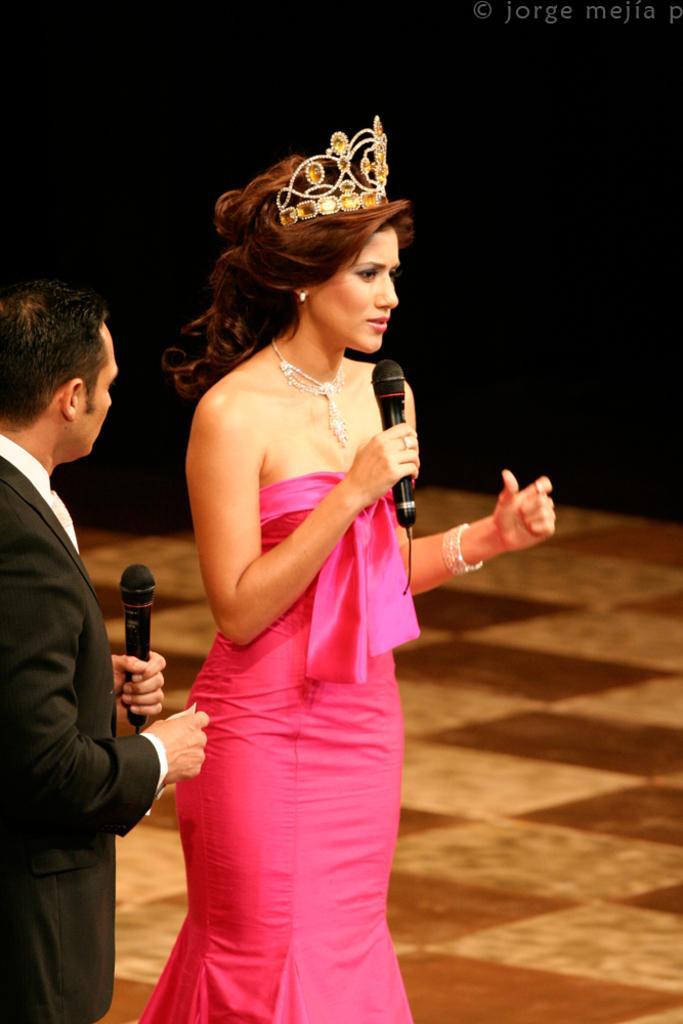Please provide a concise description of this image. In this picture we can see a man and woman, they both are holding microphones and we can see dark background, in the top right hand corner we can see some text. 